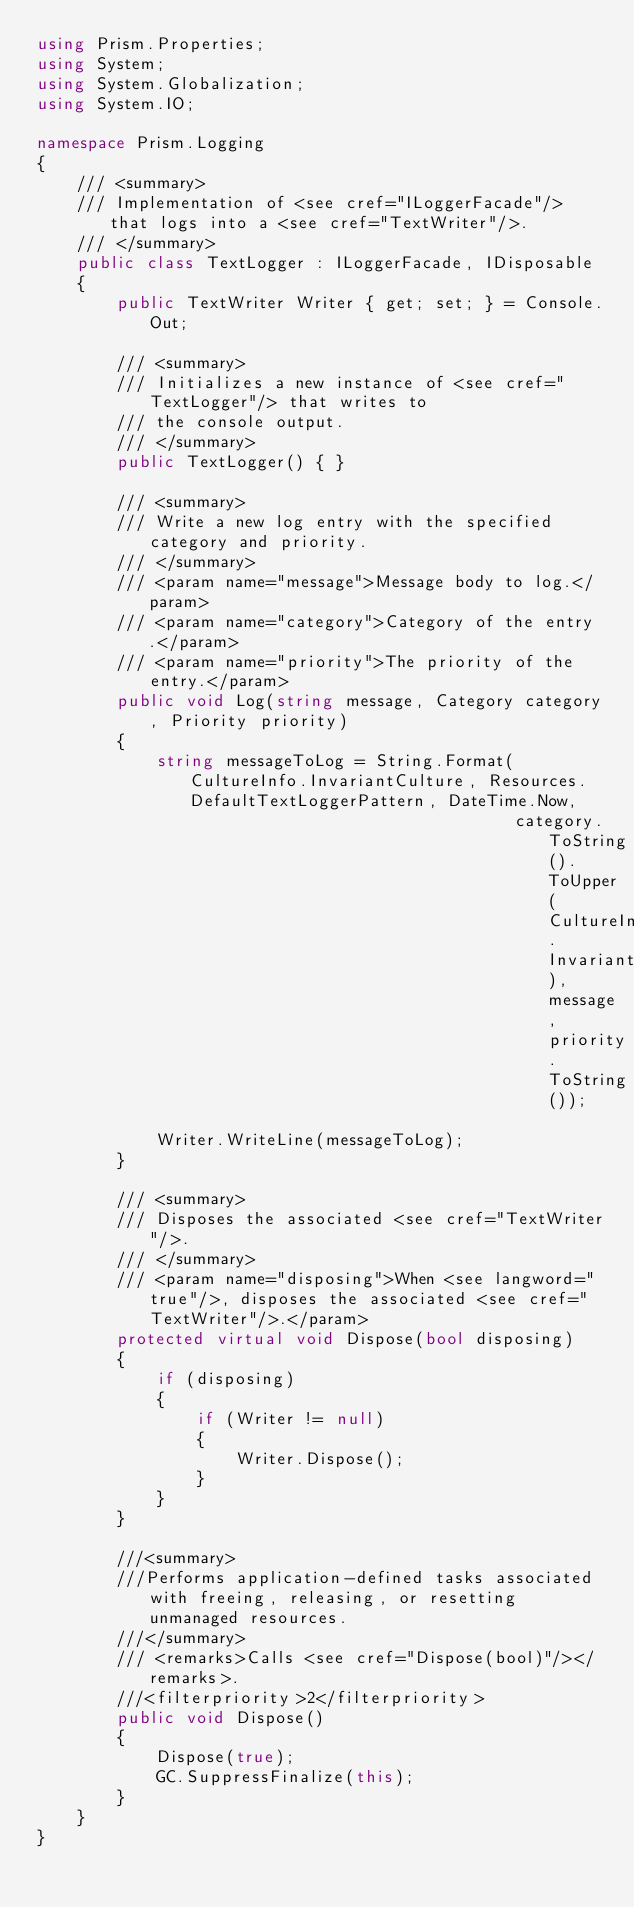Convert code to text. <code><loc_0><loc_0><loc_500><loc_500><_C#_>using Prism.Properties;
using System;
using System.Globalization;
using System.IO;

namespace Prism.Logging
{
    /// <summary>
    /// Implementation of <see cref="ILoggerFacade"/> that logs into a <see cref="TextWriter"/>.
    /// </summary>
    public class TextLogger : ILoggerFacade, IDisposable
    {
        public TextWriter Writer { get; set; } = Console.Out;

        /// <summary>
        /// Initializes a new instance of <see cref="TextLogger"/> that writes to
        /// the console output.
        /// </summary>
        public TextLogger() { }

        /// <summary>
        /// Write a new log entry with the specified category and priority.
        /// </summary>
        /// <param name="message">Message body to log.</param>
        /// <param name="category">Category of the entry.</param>
        /// <param name="priority">The priority of the entry.</param>
        public void Log(string message, Category category, Priority priority)
        {
            string messageToLog = String.Format(CultureInfo.InvariantCulture, Resources.DefaultTextLoggerPattern, DateTime.Now,
                                                category.ToString().ToUpper(CultureInfo.InvariantCulture), message, priority.ToString());

            Writer.WriteLine(messageToLog);
        }

        /// <summary>
        /// Disposes the associated <see cref="TextWriter"/>.
        /// </summary>
        /// <param name="disposing">When <see langword="true"/>, disposes the associated <see cref="TextWriter"/>.</param>
        protected virtual void Dispose(bool disposing)
        {
            if (disposing)
            {
                if (Writer != null)
                {
                    Writer.Dispose();
                }
            }
        }

        ///<summary>
        ///Performs application-defined tasks associated with freeing, releasing, or resetting unmanaged resources.
        ///</summary>
        /// <remarks>Calls <see cref="Dispose(bool)"/></remarks>.
        ///<filterpriority>2</filterpriority>
        public void Dispose()
        {
            Dispose(true);
            GC.SuppressFinalize(this);
        }
    }
}</code> 